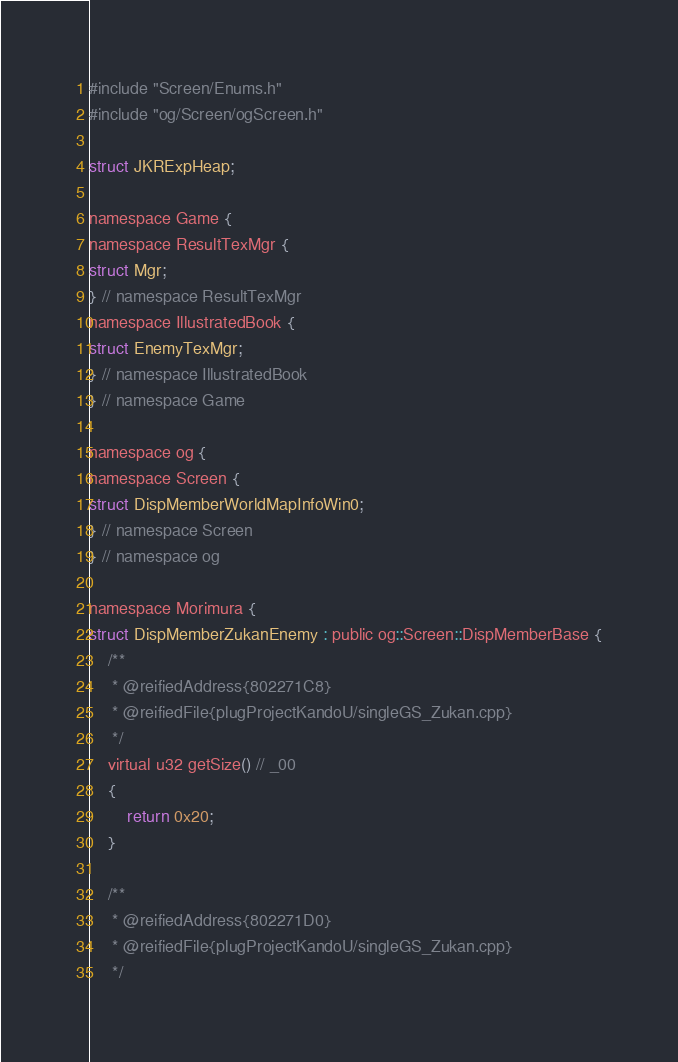Convert code to text. <code><loc_0><loc_0><loc_500><loc_500><_C_>
#include "Screen/Enums.h"
#include "og/Screen/ogScreen.h"

struct JKRExpHeap;

namespace Game {
namespace ResultTexMgr {
struct Mgr;
} // namespace ResultTexMgr
namespace IllustratedBook {
struct EnemyTexMgr;
} // namespace IllustratedBook
} // namespace Game

namespace og {
namespace Screen {
struct DispMemberWorldMapInfoWin0;
} // namespace Screen
} // namespace og

namespace Morimura {
struct DispMemberZukanEnemy : public og::Screen::DispMemberBase {
	/**
	 * @reifiedAddress{802271C8}
	 * @reifiedFile{plugProjectKandoU/singleGS_Zukan.cpp}
	 */
	virtual u32 getSize() // _00
	{
		return 0x20;
	}

	/**
	 * @reifiedAddress{802271D0}
	 * @reifiedFile{plugProjectKandoU/singleGS_Zukan.cpp}
	 */</code> 